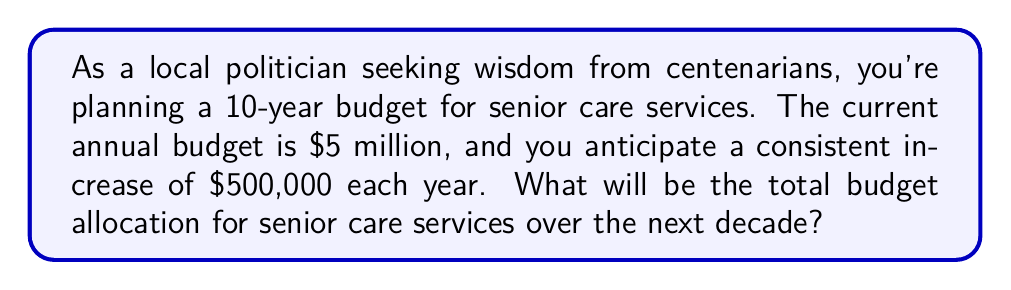Can you solve this math problem? Let's approach this step-by-step using an arithmetic sequence:

1) We have an arithmetic sequence where:
   $a_1 = 5,000,000$ (first term)
   $d = 500,000$ (common difference)
   $n = 10$ (number of terms)

2) The sequence will be:
   Year 1: $5,000,000
   Year 2: $5,500,000
   Year 3: $6,000,000
   ...and so on

3) To find the total, we need to sum this arithmetic sequence. We can use the formula:

   $S_n = \frac{n}{2}(a_1 + a_n)$

   Where $a_n$ is the last term of the sequence.

4) We can find $a_n$ using the arithmetic sequence formula:
   $a_n = a_1 + (n-1)d$
   $a_{10} = 5,000,000 + (10-1)(500,000) = 9,500,000$

5) Now we can calculate the sum:
   $S_{10} = \frac{10}{2}(5,000,000 + 9,500,000)$
   $S_{10} = 5(14,500,000) = 72,500,000$

Therefore, the total budget allocation for senior care services over the next decade will be $72,500,000.
Answer: $72,500,000 